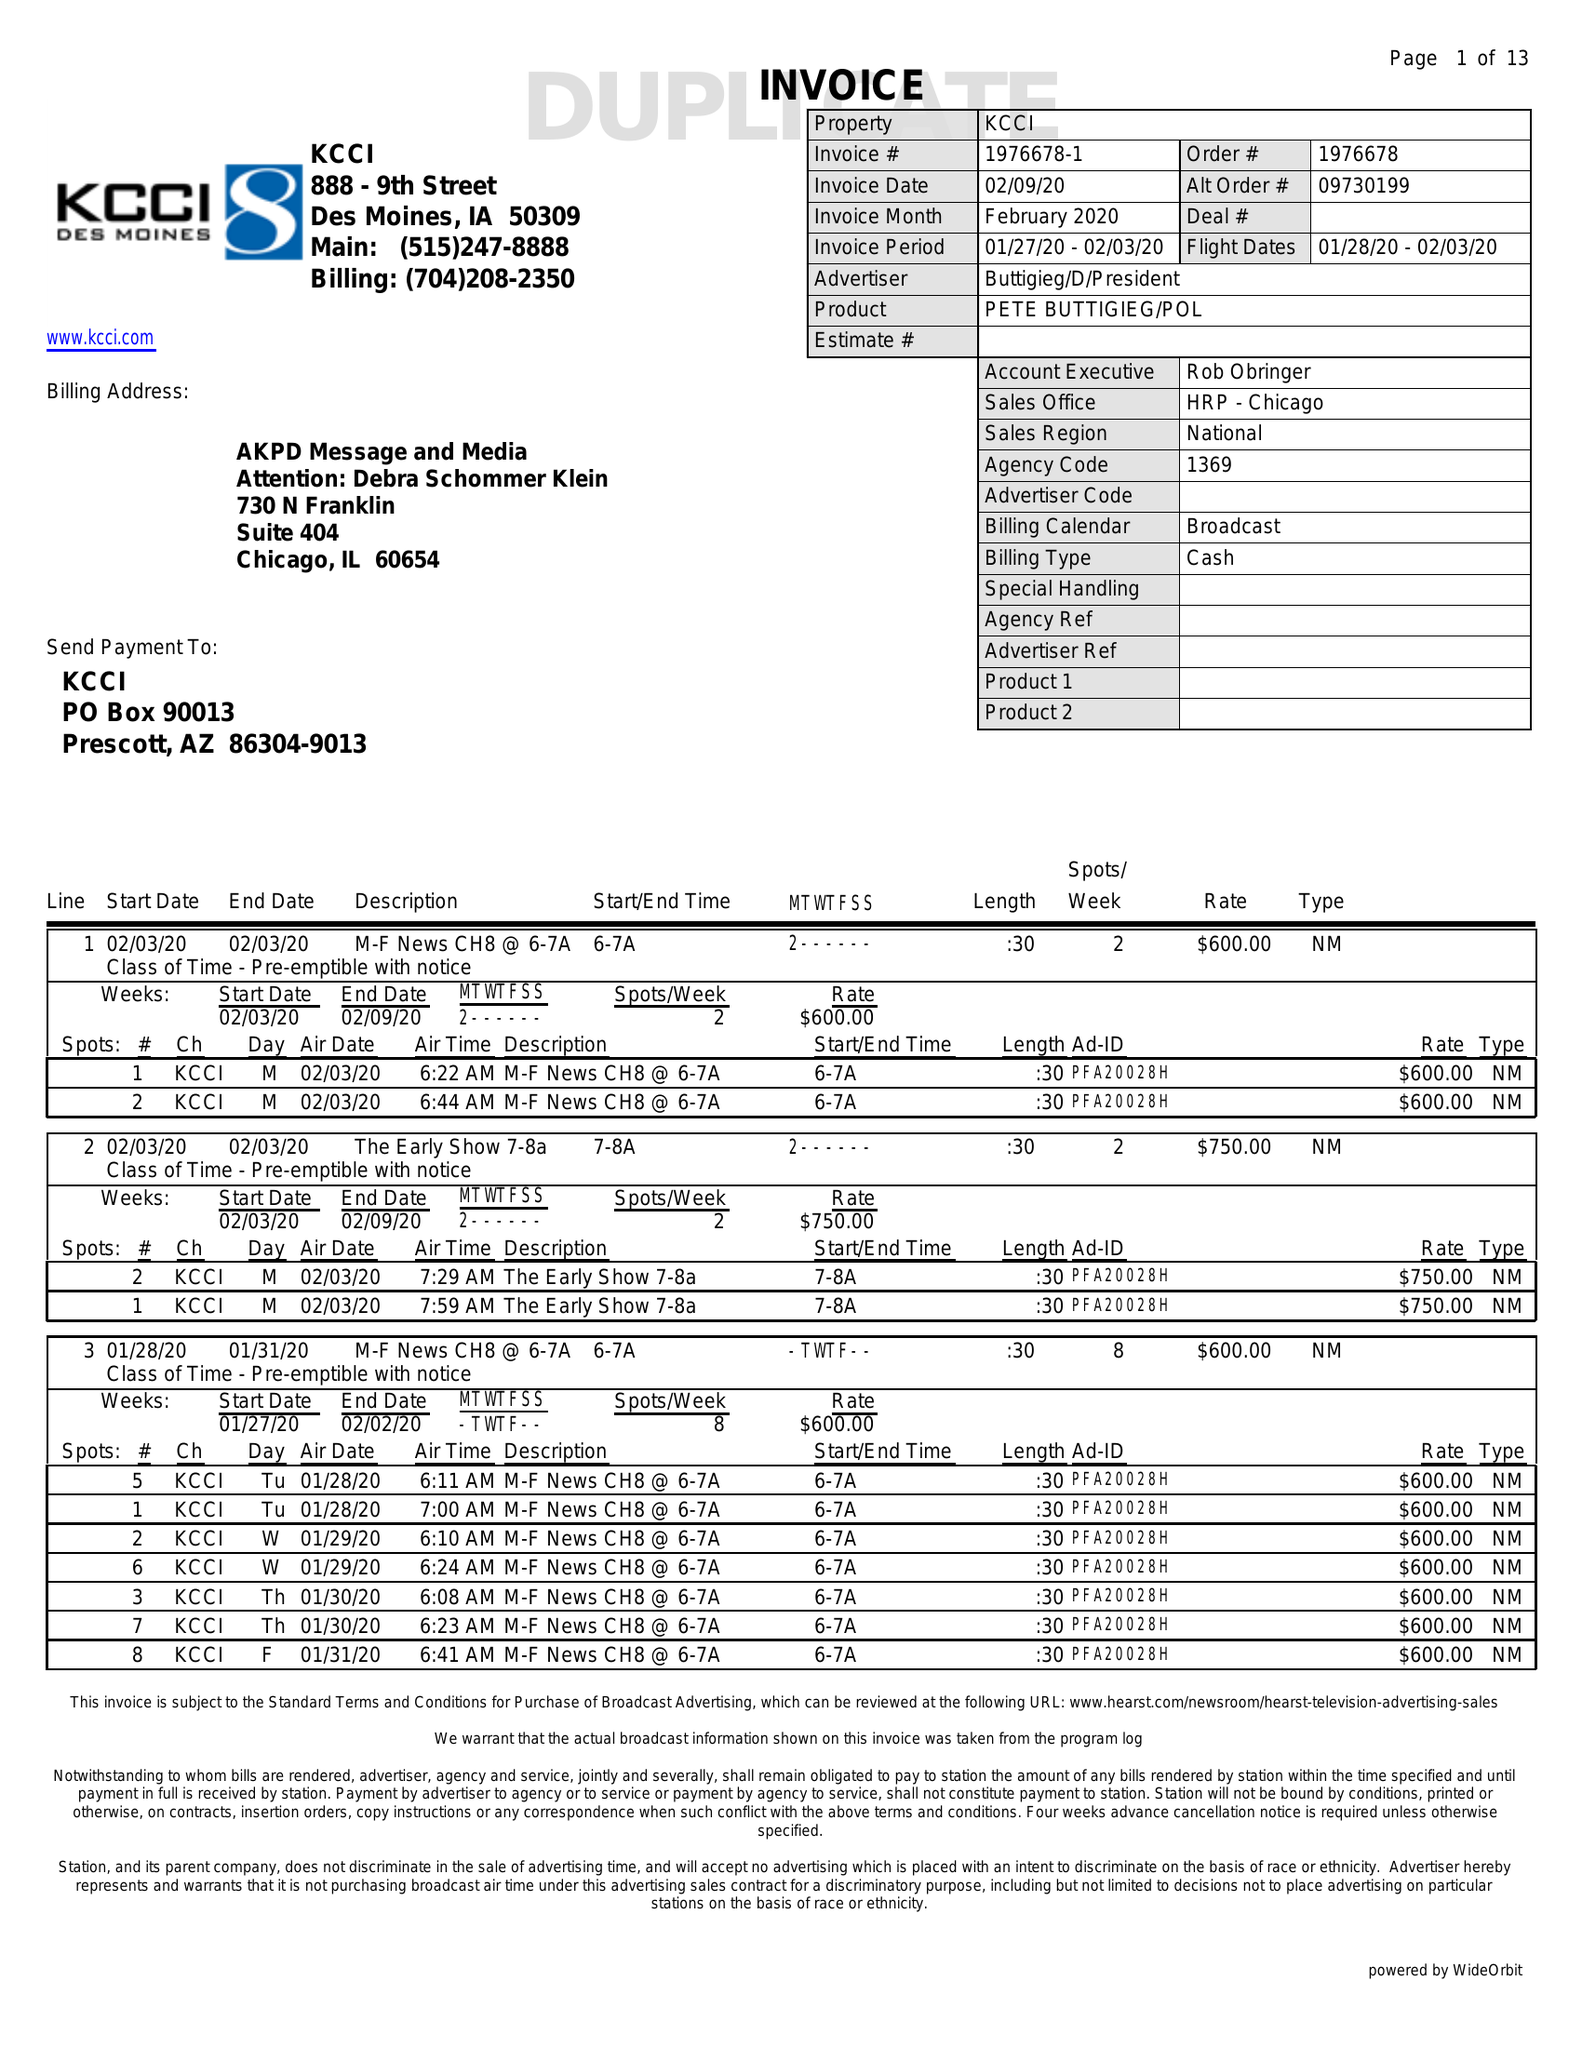What is the value for the contract_num?
Answer the question using a single word or phrase. 1976678 